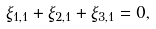Convert formula to latex. <formula><loc_0><loc_0><loc_500><loc_500>\xi _ { 1 , 1 } + \xi _ { 2 , 1 } + \xi _ { 3 , 1 } = 0 ,</formula> 